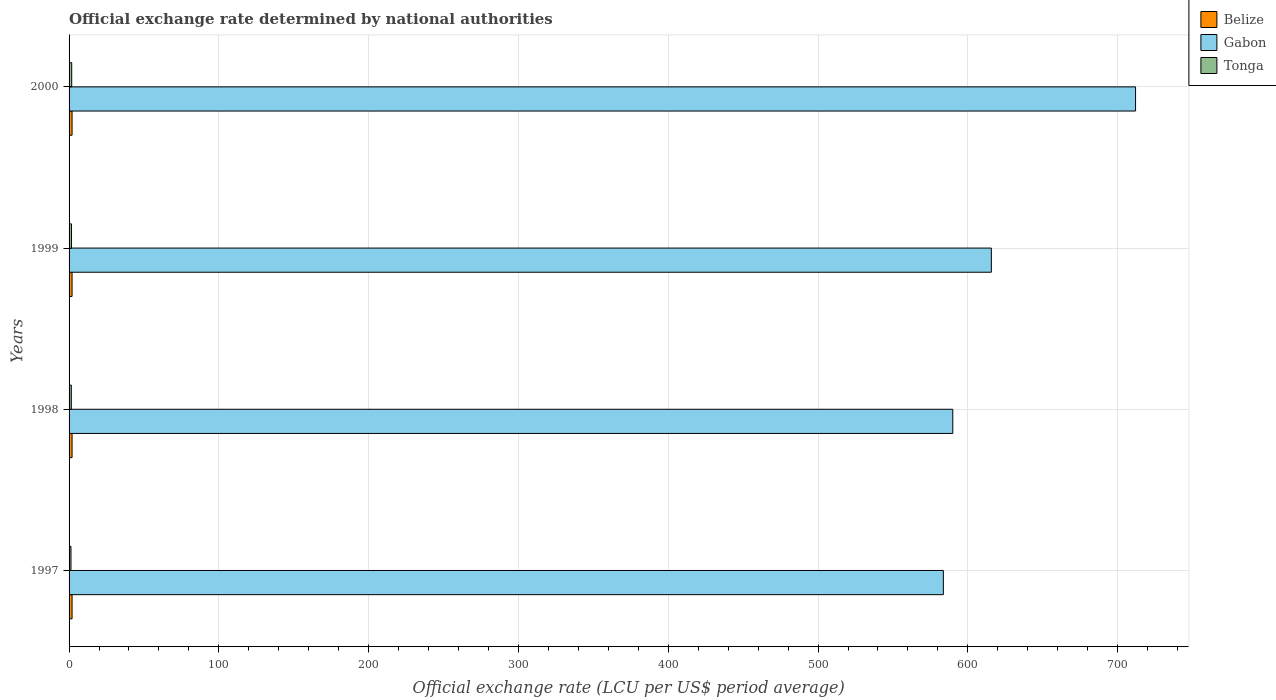How many different coloured bars are there?
Give a very brief answer. 3. Are the number of bars per tick equal to the number of legend labels?
Provide a short and direct response. Yes. How many bars are there on the 4th tick from the bottom?
Your answer should be very brief. 3. In how many cases, is the number of bars for a given year not equal to the number of legend labels?
Ensure brevity in your answer.  0. What is the official exchange rate in Gabon in 1997?
Offer a terse response. 583.67. Across all years, what is the maximum official exchange rate in Tonga?
Keep it short and to the point. 1.76. Across all years, what is the minimum official exchange rate in Tonga?
Keep it short and to the point. 1.26. In which year was the official exchange rate in Gabon minimum?
Offer a terse response. 1997. What is the total official exchange rate in Gabon in the graph?
Offer a terse response. 2501.3. What is the difference between the official exchange rate in Belize in 1998 and that in 1999?
Make the answer very short. 0. What is the difference between the official exchange rate in Tonga in 2000 and the official exchange rate in Belize in 1998?
Provide a short and direct response. -0.24. In the year 1999, what is the difference between the official exchange rate in Tonga and official exchange rate in Gabon?
Offer a terse response. -614.1. Is the difference between the official exchange rate in Tonga in 1997 and 1999 greater than the difference between the official exchange rate in Gabon in 1997 and 1999?
Offer a terse response. Yes. What is the difference between the highest and the second highest official exchange rate in Gabon?
Your answer should be compact. 96.28. What is the difference between the highest and the lowest official exchange rate in Belize?
Offer a terse response. 0. In how many years, is the official exchange rate in Gabon greater than the average official exchange rate in Gabon taken over all years?
Your response must be concise. 1. Is the sum of the official exchange rate in Gabon in 1998 and 1999 greater than the maximum official exchange rate in Belize across all years?
Provide a succinct answer. Yes. What does the 3rd bar from the top in 1998 represents?
Give a very brief answer. Belize. What does the 3rd bar from the bottom in 1997 represents?
Offer a terse response. Tonga. How many years are there in the graph?
Your response must be concise. 4. What is the difference between two consecutive major ticks on the X-axis?
Give a very brief answer. 100. Are the values on the major ticks of X-axis written in scientific E-notation?
Make the answer very short. No. Where does the legend appear in the graph?
Ensure brevity in your answer.  Top right. How many legend labels are there?
Your answer should be very brief. 3. What is the title of the graph?
Provide a short and direct response. Official exchange rate determined by national authorities. What is the label or title of the X-axis?
Your response must be concise. Official exchange rate (LCU per US$ period average). What is the Official exchange rate (LCU per US$ period average) of Belize in 1997?
Offer a very short reply. 2. What is the Official exchange rate (LCU per US$ period average) in Gabon in 1997?
Give a very brief answer. 583.67. What is the Official exchange rate (LCU per US$ period average) in Tonga in 1997?
Keep it short and to the point. 1.26. What is the Official exchange rate (LCU per US$ period average) in Gabon in 1998?
Keep it short and to the point. 589.95. What is the Official exchange rate (LCU per US$ period average) of Tonga in 1998?
Offer a very short reply. 1.49. What is the Official exchange rate (LCU per US$ period average) in Gabon in 1999?
Ensure brevity in your answer.  615.7. What is the Official exchange rate (LCU per US$ period average) of Tonga in 1999?
Keep it short and to the point. 1.6. What is the Official exchange rate (LCU per US$ period average) in Belize in 2000?
Ensure brevity in your answer.  2. What is the Official exchange rate (LCU per US$ period average) in Gabon in 2000?
Offer a terse response. 711.98. What is the Official exchange rate (LCU per US$ period average) of Tonga in 2000?
Your response must be concise. 1.76. Across all years, what is the maximum Official exchange rate (LCU per US$ period average) in Gabon?
Ensure brevity in your answer.  711.98. Across all years, what is the maximum Official exchange rate (LCU per US$ period average) in Tonga?
Keep it short and to the point. 1.76. Across all years, what is the minimum Official exchange rate (LCU per US$ period average) of Gabon?
Keep it short and to the point. 583.67. Across all years, what is the minimum Official exchange rate (LCU per US$ period average) in Tonga?
Offer a very short reply. 1.26. What is the total Official exchange rate (LCU per US$ period average) of Gabon in the graph?
Provide a succinct answer. 2501.3. What is the total Official exchange rate (LCU per US$ period average) of Tonga in the graph?
Your answer should be compact. 6.11. What is the difference between the Official exchange rate (LCU per US$ period average) of Belize in 1997 and that in 1998?
Your answer should be compact. 0. What is the difference between the Official exchange rate (LCU per US$ period average) of Gabon in 1997 and that in 1998?
Give a very brief answer. -6.28. What is the difference between the Official exchange rate (LCU per US$ period average) in Tonga in 1997 and that in 1998?
Give a very brief answer. -0.23. What is the difference between the Official exchange rate (LCU per US$ period average) of Gabon in 1997 and that in 1999?
Your answer should be compact. -32.03. What is the difference between the Official exchange rate (LCU per US$ period average) of Tonga in 1997 and that in 1999?
Your answer should be very brief. -0.34. What is the difference between the Official exchange rate (LCU per US$ period average) in Gabon in 1997 and that in 2000?
Your answer should be very brief. -128.31. What is the difference between the Official exchange rate (LCU per US$ period average) in Tonga in 1997 and that in 2000?
Provide a short and direct response. -0.49. What is the difference between the Official exchange rate (LCU per US$ period average) of Gabon in 1998 and that in 1999?
Provide a short and direct response. -25.75. What is the difference between the Official exchange rate (LCU per US$ period average) in Tonga in 1998 and that in 1999?
Offer a very short reply. -0.11. What is the difference between the Official exchange rate (LCU per US$ period average) in Gabon in 1998 and that in 2000?
Ensure brevity in your answer.  -122.02. What is the difference between the Official exchange rate (LCU per US$ period average) in Tonga in 1998 and that in 2000?
Your response must be concise. -0.27. What is the difference between the Official exchange rate (LCU per US$ period average) in Gabon in 1999 and that in 2000?
Give a very brief answer. -96.28. What is the difference between the Official exchange rate (LCU per US$ period average) in Tonga in 1999 and that in 2000?
Your answer should be compact. -0.16. What is the difference between the Official exchange rate (LCU per US$ period average) of Belize in 1997 and the Official exchange rate (LCU per US$ period average) of Gabon in 1998?
Make the answer very short. -587.95. What is the difference between the Official exchange rate (LCU per US$ period average) of Belize in 1997 and the Official exchange rate (LCU per US$ period average) of Tonga in 1998?
Keep it short and to the point. 0.51. What is the difference between the Official exchange rate (LCU per US$ period average) in Gabon in 1997 and the Official exchange rate (LCU per US$ period average) in Tonga in 1998?
Ensure brevity in your answer.  582.18. What is the difference between the Official exchange rate (LCU per US$ period average) in Belize in 1997 and the Official exchange rate (LCU per US$ period average) in Gabon in 1999?
Provide a short and direct response. -613.7. What is the difference between the Official exchange rate (LCU per US$ period average) of Belize in 1997 and the Official exchange rate (LCU per US$ period average) of Tonga in 1999?
Ensure brevity in your answer.  0.4. What is the difference between the Official exchange rate (LCU per US$ period average) of Gabon in 1997 and the Official exchange rate (LCU per US$ period average) of Tonga in 1999?
Provide a succinct answer. 582.07. What is the difference between the Official exchange rate (LCU per US$ period average) of Belize in 1997 and the Official exchange rate (LCU per US$ period average) of Gabon in 2000?
Provide a succinct answer. -709.98. What is the difference between the Official exchange rate (LCU per US$ period average) of Belize in 1997 and the Official exchange rate (LCU per US$ period average) of Tonga in 2000?
Make the answer very short. 0.24. What is the difference between the Official exchange rate (LCU per US$ period average) of Gabon in 1997 and the Official exchange rate (LCU per US$ period average) of Tonga in 2000?
Give a very brief answer. 581.91. What is the difference between the Official exchange rate (LCU per US$ period average) of Belize in 1998 and the Official exchange rate (LCU per US$ period average) of Gabon in 1999?
Your answer should be compact. -613.7. What is the difference between the Official exchange rate (LCU per US$ period average) in Belize in 1998 and the Official exchange rate (LCU per US$ period average) in Tonga in 1999?
Make the answer very short. 0.4. What is the difference between the Official exchange rate (LCU per US$ period average) in Gabon in 1998 and the Official exchange rate (LCU per US$ period average) in Tonga in 1999?
Make the answer very short. 588.35. What is the difference between the Official exchange rate (LCU per US$ period average) in Belize in 1998 and the Official exchange rate (LCU per US$ period average) in Gabon in 2000?
Make the answer very short. -709.98. What is the difference between the Official exchange rate (LCU per US$ period average) of Belize in 1998 and the Official exchange rate (LCU per US$ period average) of Tonga in 2000?
Your answer should be very brief. 0.24. What is the difference between the Official exchange rate (LCU per US$ period average) of Gabon in 1998 and the Official exchange rate (LCU per US$ period average) of Tonga in 2000?
Your response must be concise. 588.19. What is the difference between the Official exchange rate (LCU per US$ period average) of Belize in 1999 and the Official exchange rate (LCU per US$ period average) of Gabon in 2000?
Offer a terse response. -709.98. What is the difference between the Official exchange rate (LCU per US$ period average) in Belize in 1999 and the Official exchange rate (LCU per US$ period average) in Tonga in 2000?
Ensure brevity in your answer.  0.24. What is the difference between the Official exchange rate (LCU per US$ period average) in Gabon in 1999 and the Official exchange rate (LCU per US$ period average) in Tonga in 2000?
Your answer should be compact. 613.94. What is the average Official exchange rate (LCU per US$ period average) of Belize per year?
Make the answer very short. 2. What is the average Official exchange rate (LCU per US$ period average) in Gabon per year?
Provide a short and direct response. 625.32. What is the average Official exchange rate (LCU per US$ period average) of Tonga per year?
Offer a terse response. 1.53. In the year 1997, what is the difference between the Official exchange rate (LCU per US$ period average) in Belize and Official exchange rate (LCU per US$ period average) in Gabon?
Provide a short and direct response. -581.67. In the year 1997, what is the difference between the Official exchange rate (LCU per US$ period average) in Belize and Official exchange rate (LCU per US$ period average) in Tonga?
Your answer should be compact. 0.74. In the year 1997, what is the difference between the Official exchange rate (LCU per US$ period average) of Gabon and Official exchange rate (LCU per US$ period average) of Tonga?
Make the answer very short. 582.41. In the year 1998, what is the difference between the Official exchange rate (LCU per US$ period average) of Belize and Official exchange rate (LCU per US$ period average) of Gabon?
Offer a very short reply. -587.95. In the year 1998, what is the difference between the Official exchange rate (LCU per US$ period average) of Belize and Official exchange rate (LCU per US$ period average) of Tonga?
Make the answer very short. 0.51. In the year 1998, what is the difference between the Official exchange rate (LCU per US$ period average) in Gabon and Official exchange rate (LCU per US$ period average) in Tonga?
Offer a very short reply. 588.46. In the year 1999, what is the difference between the Official exchange rate (LCU per US$ period average) in Belize and Official exchange rate (LCU per US$ period average) in Gabon?
Your response must be concise. -613.7. In the year 1999, what is the difference between the Official exchange rate (LCU per US$ period average) of Belize and Official exchange rate (LCU per US$ period average) of Tonga?
Ensure brevity in your answer.  0.4. In the year 1999, what is the difference between the Official exchange rate (LCU per US$ period average) of Gabon and Official exchange rate (LCU per US$ period average) of Tonga?
Keep it short and to the point. 614.1. In the year 2000, what is the difference between the Official exchange rate (LCU per US$ period average) in Belize and Official exchange rate (LCU per US$ period average) in Gabon?
Your answer should be compact. -709.98. In the year 2000, what is the difference between the Official exchange rate (LCU per US$ period average) of Belize and Official exchange rate (LCU per US$ period average) of Tonga?
Your answer should be compact. 0.24. In the year 2000, what is the difference between the Official exchange rate (LCU per US$ period average) of Gabon and Official exchange rate (LCU per US$ period average) of Tonga?
Offer a terse response. 710.22. What is the ratio of the Official exchange rate (LCU per US$ period average) of Belize in 1997 to that in 1998?
Ensure brevity in your answer.  1. What is the ratio of the Official exchange rate (LCU per US$ period average) in Tonga in 1997 to that in 1998?
Your response must be concise. 0.85. What is the ratio of the Official exchange rate (LCU per US$ period average) of Belize in 1997 to that in 1999?
Keep it short and to the point. 1. What is the ratio of the Official exchange rate (LCU per US$ period average) of Gabon in 1997 to that in 1999?
Provide a short and direct response. 0.95. What is the ratio of the Official exchange rate (LCU per US$ period average) in Tonga in 1997 to that in 1999?
Make the answer very short. 0.79. What is the ratio of the Official exchange rate (LCU per US$ period average) of Belize in 1997 to that in 2000?
Give a very brief answer. 1. What is the ratio of the Official exchange rate (LCU per US$ period average) of Gabon in 1997 to that in 2000?
Give a very brief answer. 0.82. What is the ratio of the Official exchange rate (LCU per US$ period average) of Tonga in 1997 to that in 2000?
Your answer should be compact. 0.72. What is the ratio of the Official exchange rate (LCU per US$ period average) in Belize in 1998 to that in 1999?
Give a very brief answer. 1. What is the ratio of the Official exchange rate (LCU per US$ period average) of Gabon in 1998 to that in 1999?
Ensure brevity in your answer.  0.96. What is the ratio of the Official exchange rate (LCU per US$ period average) in Tonga in 1998 to that in 1999?
Offer a very short reply. 0.93. What is the ratio of the Official exchange rate (LCU per US$ period average) of Belize in 1998 to that in 2000?
Your answer should be compact. 1. What is the ratio of the Official exchange rate (LCU per US$ period average) in Gabon in 1998 to that in 2000?
Ensure brevity in your answer.  0.83. What is the ratio of the Official exchange rate (LCU per US$ period average) of Tonga in 1998 to that in 2000?
Ensure brevity in your answer.  0.85. What is the ratio of the Official exchange rate (LCU per US$ period average) of Gabon in 1999 to that in 2000?
Ensure brevity in your answer.  0.86. What is the ratio of the Official exchange rate (LCU per US$ period average) of Tonga in 1999 to that in 2000?
Provide a short and direct response. 0.91. What is the difference between the highest and the second highest Official exchange rate (LCU per US$ period average) in Belize?
Your response must be concise. 0. What is the difference between the highest and the second highest Official exchange rate (LCU per US$ period average) in Gabon?
Offer a terse response. 96.28. What is the difference between the highest and the second highest Official exchange rate (LCU per US$ period average) of Tonga?
Your response must be concise. 0.16. What is the difference between the highest and the lowest Official exchange rate (LCU per US$ period average) of Gabon?
Make the answer very short. 128.31. What is the difference between the highest and the lowest Official exchange rate (LCU per US$ period average) of Tonga?
Provide a succinct answer. 0.49. 